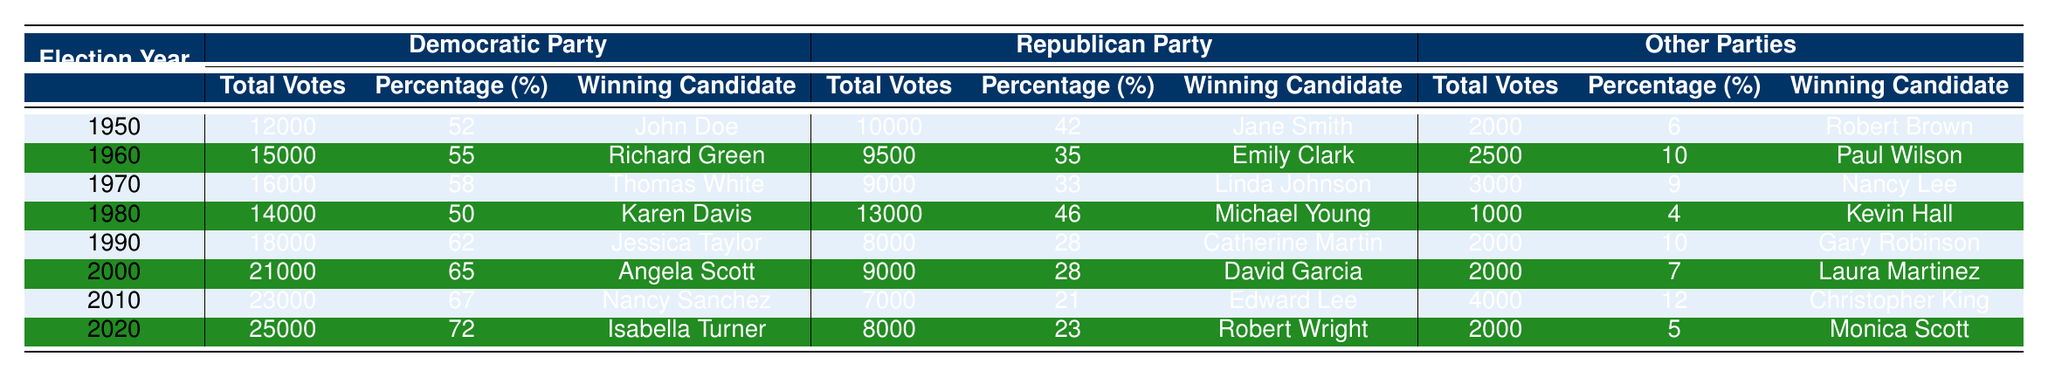What percentage of votes did the Democratic Party receive in the year 2000? In the year 2000, the table shows that the Democratic Party received 65% of the votes.
Answer: 65% Which candidate won the 1990 election? According to the table, Jessica Taylor was the winning candidate for the Democratic Party in 1990.
Answer: Jessica Taylor How many total votes did the Republican Party receive in 1960? In the year 1960, the table indicates that the Republican Party received 9500 votes.
Answer: 9500 What is the average percentage of votes received by the Other Parties over all elections? The percentages for Other Parties are: 6%, 10%, 9%, 4%, 10%, 7%, 12%, and 5%. Summing them gives 6 + 10 + 9 + 4 + 10 + 7 + 12 + 5 = 63. There are 8 elections, so the average is 63 / 8 = 7.875%.
Answer: 7.875% Which party had the highest total votes in any election year? Looking at the total votes across all parties and years, in 2020, the Democratic Party received the highest total votes at 25000 votes.
Answer: Democratic Party In what election year did the Republican Party receive the lowest percentage of the votes? The Republican Party received the lowest percentage of 21% in the year 2010.
Answer: 2010 Was the candidate with the highest total votes always from the Democratic Party? Yes, in all the election years from 1950 to 2020, the candidate with the highest total votes was consistently from the Democratic Party.
Answer: Yes What was the difference in total votes between the Democratic Party and Republican Party in 1980? In 1980, the Democratic Party received 14000 votes and the Republican Party received 13000 votes. The difference is 14000 - 13000 = 1000 votes.
Answer: 1000 Did the percentage of votes for the Democratic Party increase every decade? By reviewing the percentages: 52%, 55%, 58%, 50%, 62%, 65%, 67%, and 72%, we can see there is a decrease from 58% in 1970 to 50% in 1980. Thus, the percentage did not increase every decade.
Answer: No In which year did the Other Parties achieve the highest percentage of votes? In the year 1960, the Other Parties achieved the highest percentage with 10%.
Answer: 1960 